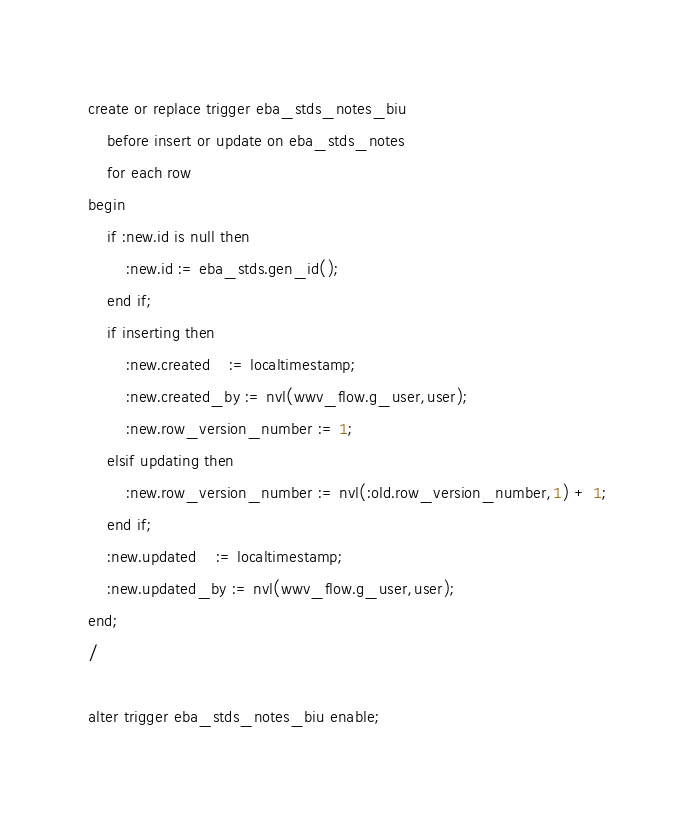Convert code to text. <code><loc_0><loc_0><loc_500><loc_500><_SQL_>create or replace trigger eba_stds_notes_biu
    before insert or update on eba_stds_notes
    for each row
begin
    if :new.id is null then
        :new.id := eba_stds.gen_id();
    end if;
    if inserting then
        :new.created    := localtimestamp;
        :new.created_by := nvl(wwv_flow.g_user,user);
        :new.row_version_number := 1;
    elsif updating then
        :new.row_version_number := nvl(:old.row_version_number,1) + 1;
    end if;
    :new.updated    := localtimestamp;
    :new.updated_by := nvl(wwv_flow.g_user,user);
end;
/

alter trigger eba_stds_notes_biu enable;</code> 